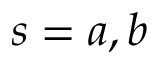Convert formula to latex. <formula><loc_0><loc_0><loc_500><loc_500>s = a , b</formula> 